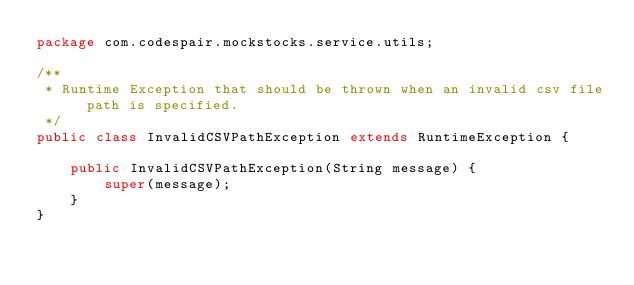<code> <loc_0><loc_0><loc_500><loc_500><_Java_>package com.codespair.mockstocks.service.utils;

/**
 * Runtime Exception that should be thrown when an invalid csv file path is specified.
 */
public class InvalidCSVPathException extends RuntimeException {

    public InvalidCSVPathException(String message) {
        super(message);
    }
}
</code> 